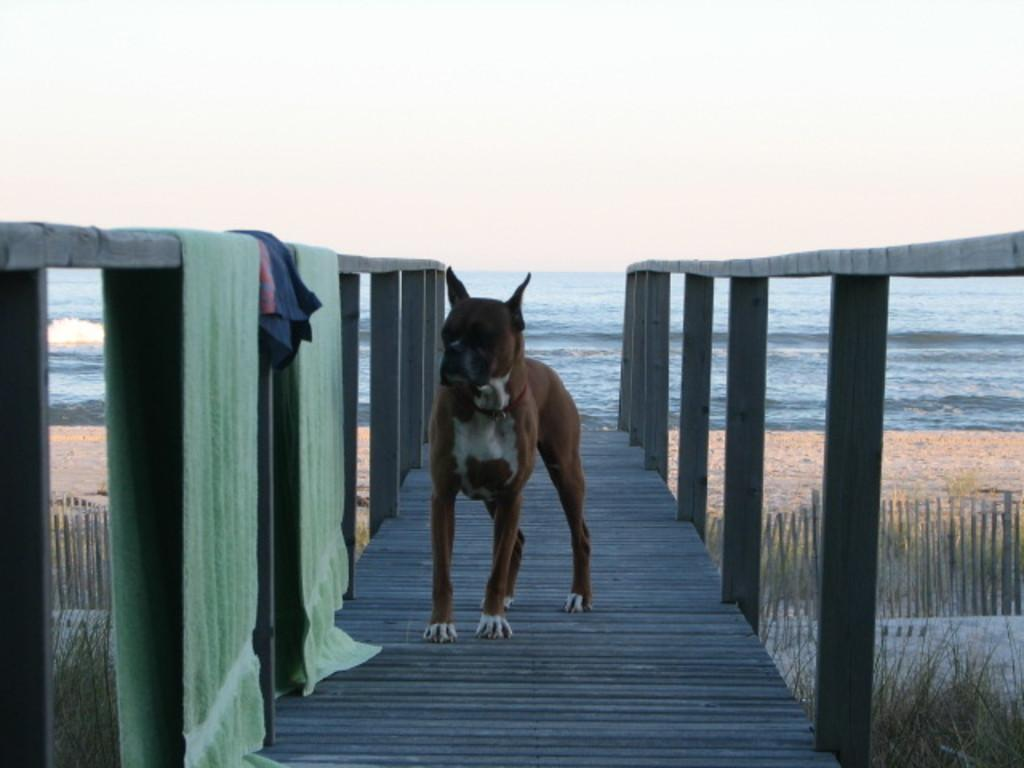What animal can be seen on the pathway in the image? There is a dog on the pathway in the image. What items are hanging on the railing? There are towels on the railing in the image. What type of vegetation is visible in the image? There are plants visible in the image. What type of barrier is present in the image? There is a fence in the image. What large body of water is visible in the image? There is a large water body in the image. What is the condition of the sky in the image? The sky is visible in the image and appears cloudy. What type of cake is being served by the maid in the image? There is no maid or cake present in the image. What test is being conducted on the plants in the image? There is no test being conducted on the plants in the image; they are simply visible. 